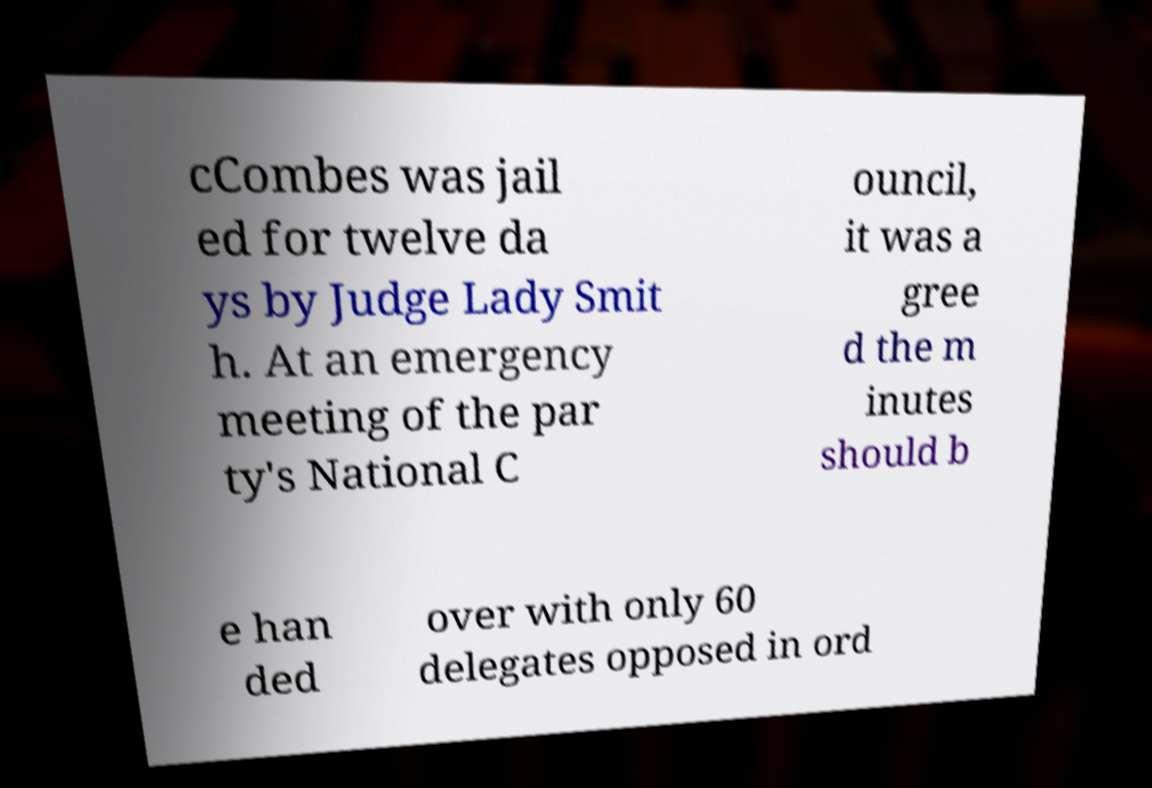Could you extract and type out the text from this image? cCombes was jail ed for twelve da ys by Judge Lady Smit h. At an emergency meeting of the par ty's National C ouncil, it was a gree d the m inutes should b e han ded over with only 60 delegates opposed in ord 